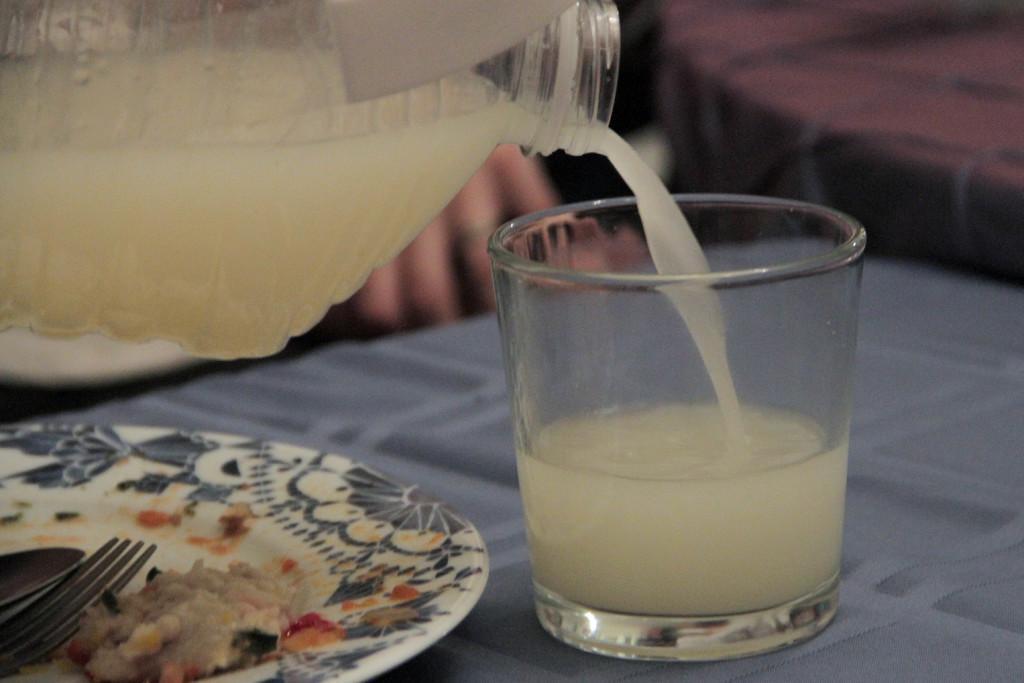How would you summarize this image in a sentence or two? In the foreground of the picture we can see glass, bottle, drink, plate, wood and a table. The background is blurred. 